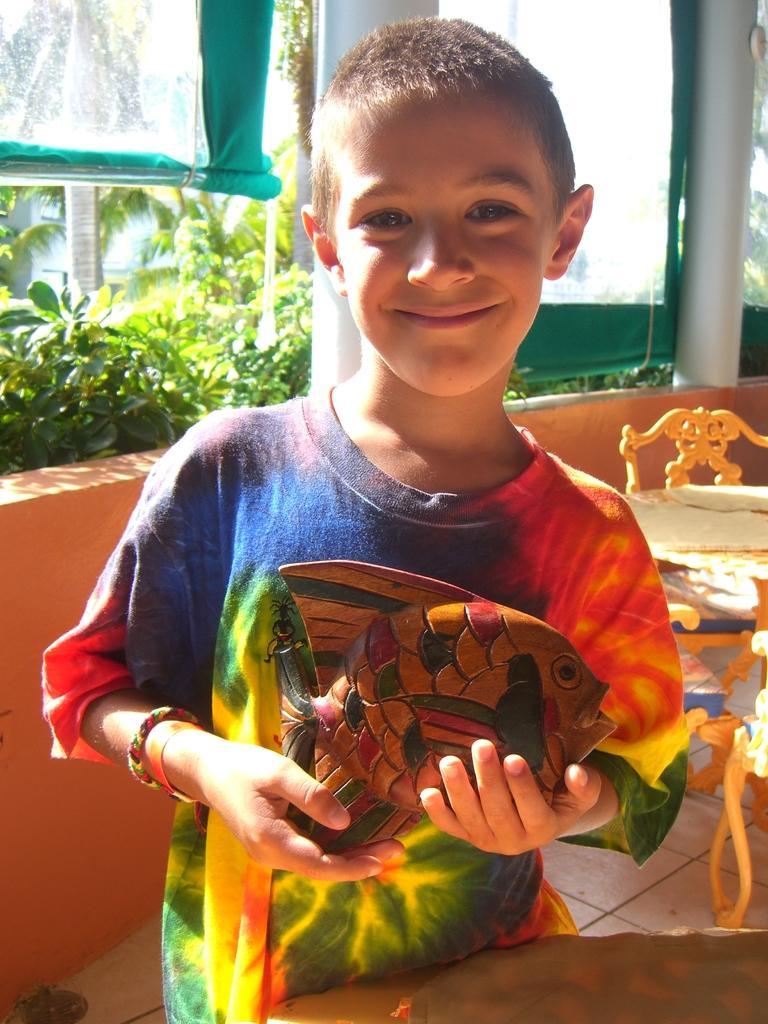How would you summarize this image in a sentence or two? In this image we can see a boy standing and holding a figurine. We can see tables and chairs. In the background there are curtains, plants and trees. There is a wall and we can see a rod. 